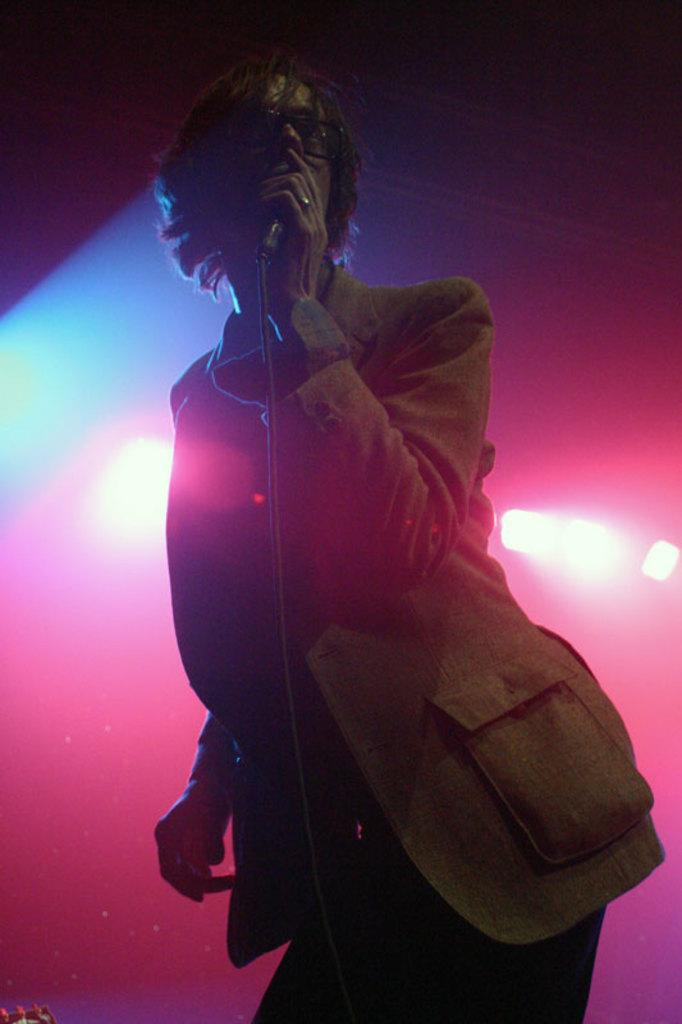What is present in the image? There is a person in the image. Can you describe the person's attire? The person is wearing clothes. What is the person holding in the image? The person is holding a microphone with his hand. What type of oil is being used for the dinner in the image? There is no dinner or oil present in the image; it features a person holding a microphone. 